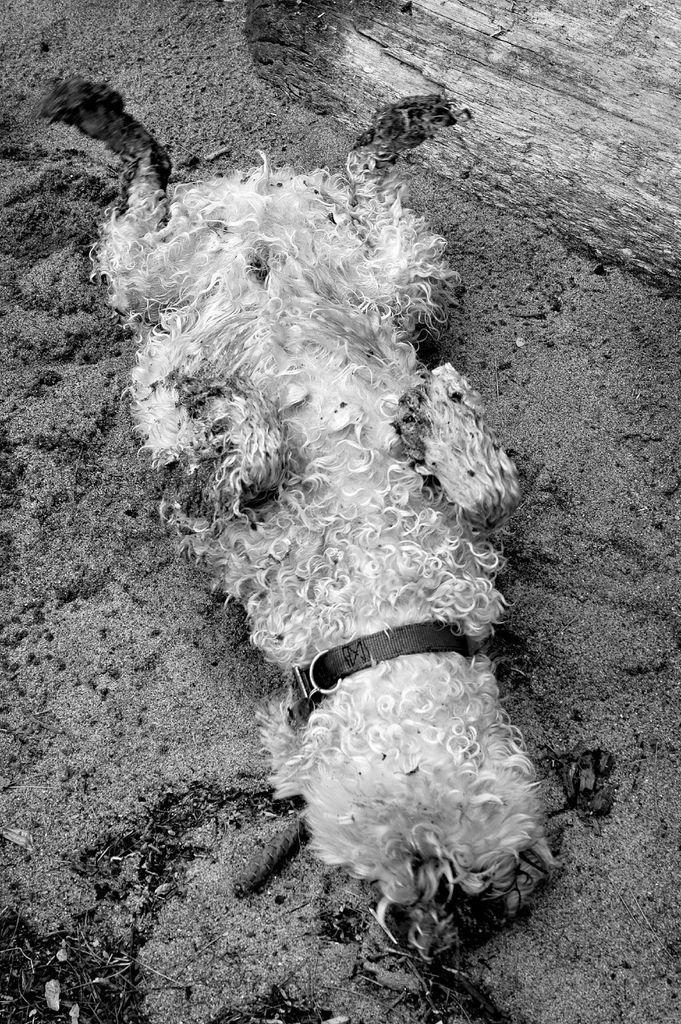Please provide a concise description of this image. In this picture I can see a dog on the ground and looks like a tree bark in the back. 